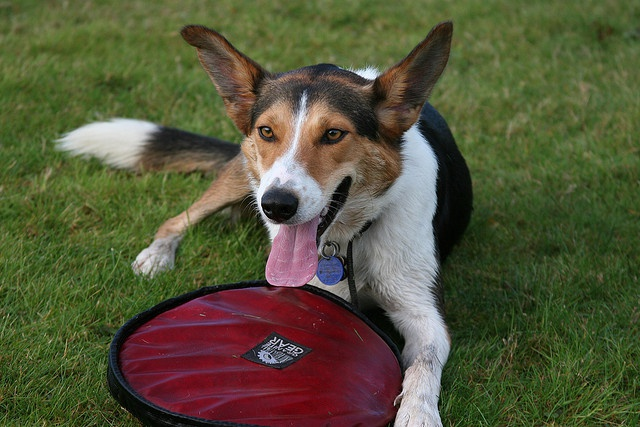Describe the objects in this image and their specific colors. I can see dog in darkgreen, black, gray, darkgray, and lightgray tones and frisbee in darkgreen, maroon, black, and purple tones in this image. 